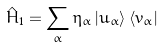Convert formula to latex. <formula><loc_0><loc_0><loc_500><loc_500>\hat { H } _ { 1 } = \sum _ { \alpha } \eta _ { \alpha } \left | u _ { \alpha } \right \rangle \left \langle v _ { \alpha } \right |</formula> 